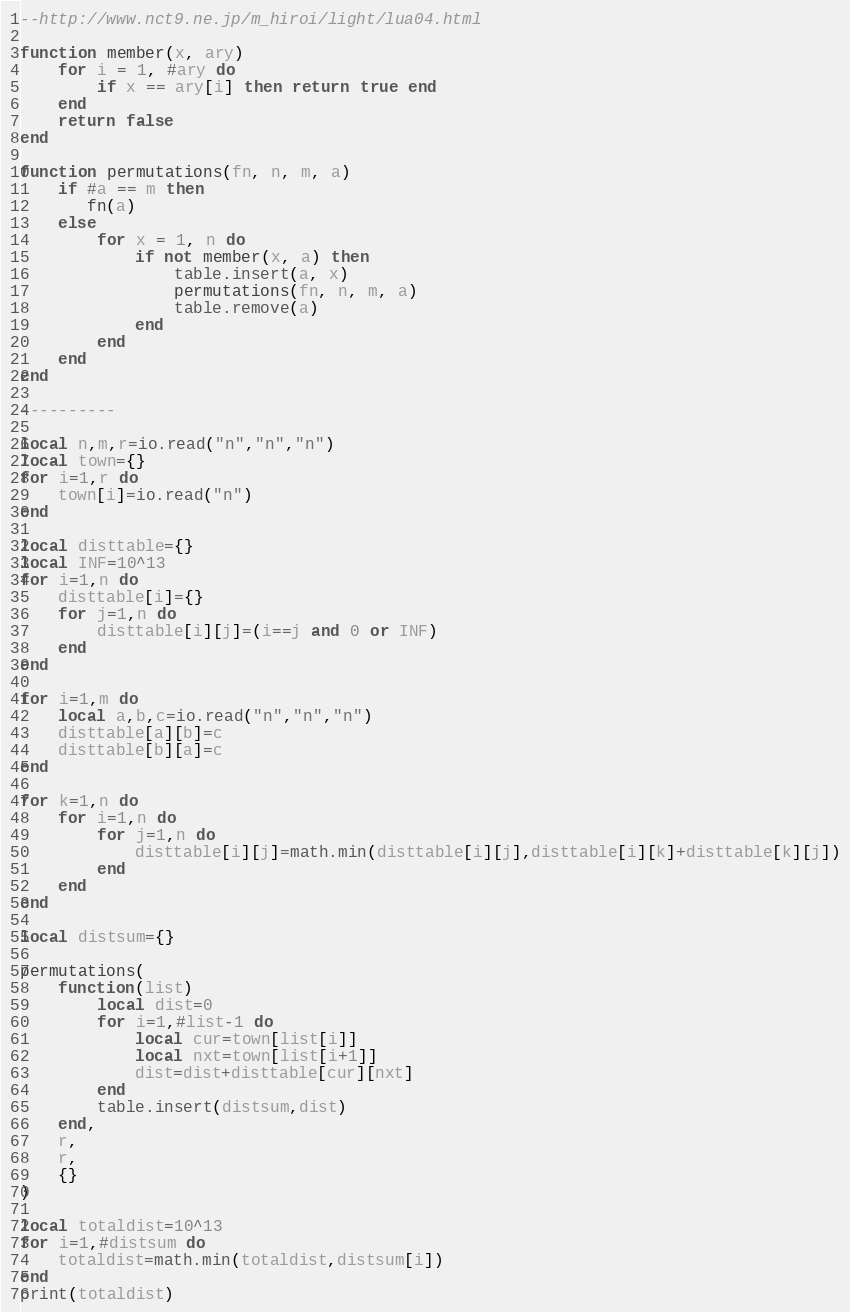<code> <loc_0><loc_0><loc_500><loc_500><_Lua_>--http://www.nct9.ne.jp/m_hiroi/light/lua04.html

function member(x, ary)
    for i = 1, #ary do
        if x == ary[i] then return true end
    end
    return false
end
  
function permutations(fn, n, m, a)
    if #a == m then
       fn(a)
    else
        for x = 1, n do
            if not member(x, a) then
                table.insert(a, x)
                permutations(fn, n, m, a)
                table.remove(a)
            end
        end
    end
end

----------

local n,m,r=io.read("n","n","n")
local town={}
for i=1,r do
    town[i]=io.read("n")
end

local disttable={}
local INF=10^13
for i=1,n do
    disttable[i]={}
    for j=1,n do
        disttable[i][j]=(i==j and 0 or INF)
    end
end

for i=1,m do
    local a,b,c=io.read("n","n","n")
    disttable[a][b]=c
    disttable[b][a]=c
end

for k=1,n do
    for i=1,n do
        for j=1,n do
            disttable[i][j]=math.min(disttable[i][j],disttable[i][k]+disttable[k][j])
        end
    end
end

local distsum={}

permutations(
    function(list)
        local dist=0
        for i=1,#list-1 do
            local cur=town[list[i]]
            local nxt=town[list[i+1]]
            dist=dist+disttable[cur][nxt]
        end
        table.insert(distsum,dist)
    end, 
    r, 
    r, 
    {}
)

local totaldist=10^13
for i=1,#distsum do
    totaldist=math.min(totaldist,distsum[i])
end
print(totaldist)</code> 